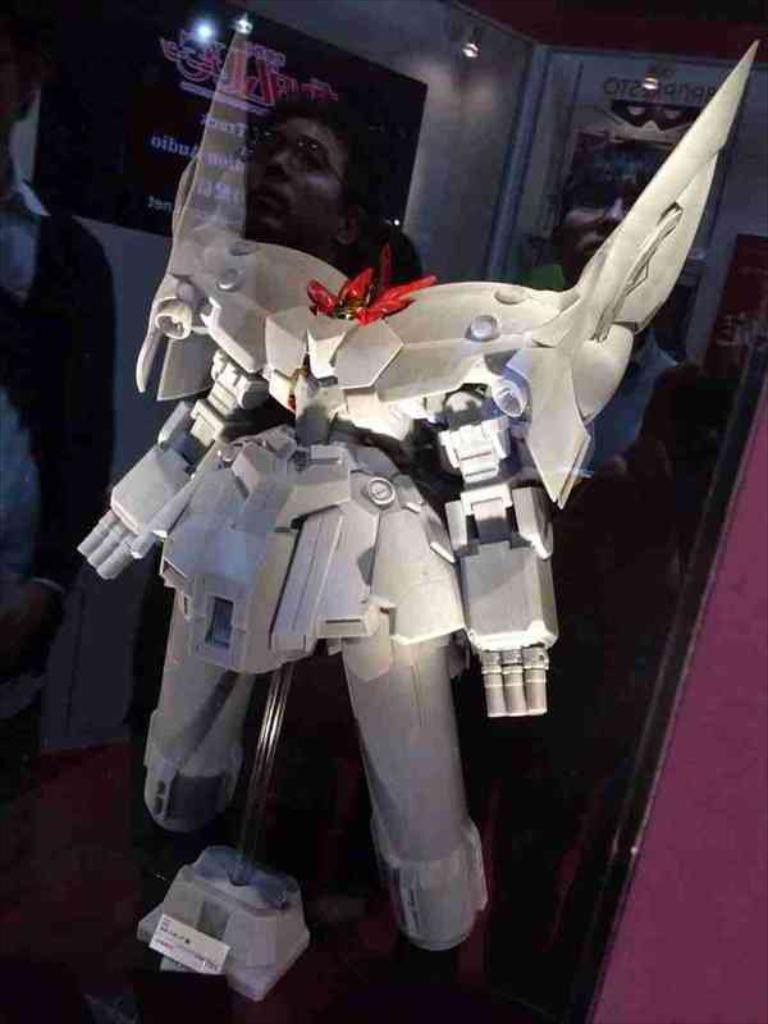What is the main subject in the image? There is a robot in the image. How is the robot positioned in the image? The robot is on a stand. What can be seen in the background of the image? There is a wall with posters in the background of the image. What type of lighting is present in the image? There are lights visible in the image. What type of whip is the robot using in the image? There is no whip present in the image; the robot is simply standing on a stand. 